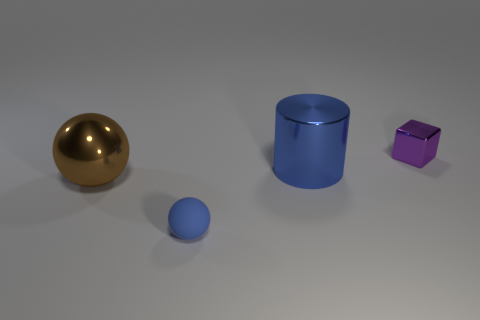Add 3 red rubber blocks. How many objects exist? 7 Subtract all cylinders. How many objects are left? 3 Subtract 0 brown cylinders. How many objects are left? 4 Subtract all small blue rubber balls. Subtract all small objects. How many objects are left? 1 Add 1 tiny purple shiny blocks. How many tiny purple shiny blocks are left? 2 Add 4 small gray cylinders. How many small gray cylinders exist? 4 